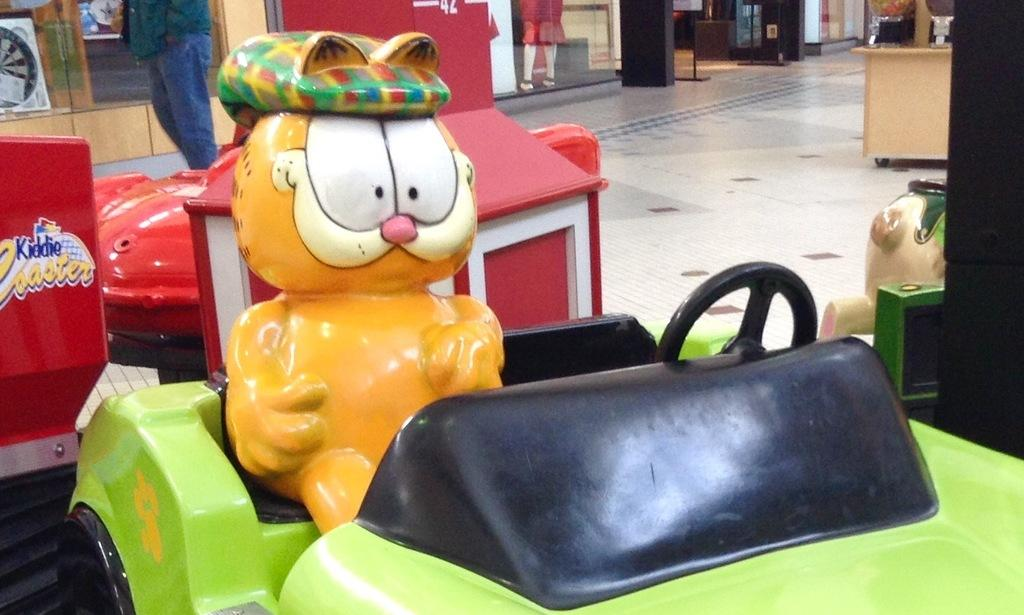What is the toy sitting on in the image? There is a toy sitting on a toy car in the image. What color is the toy car? The toy car is green in color. Can you describe the background of the image? There is a red color car behind the green car in the image. What type of plantation can be seen in the image? There is no plantation present in the image. Is there a goat visible in the image? No, there is no goat present in the image. 